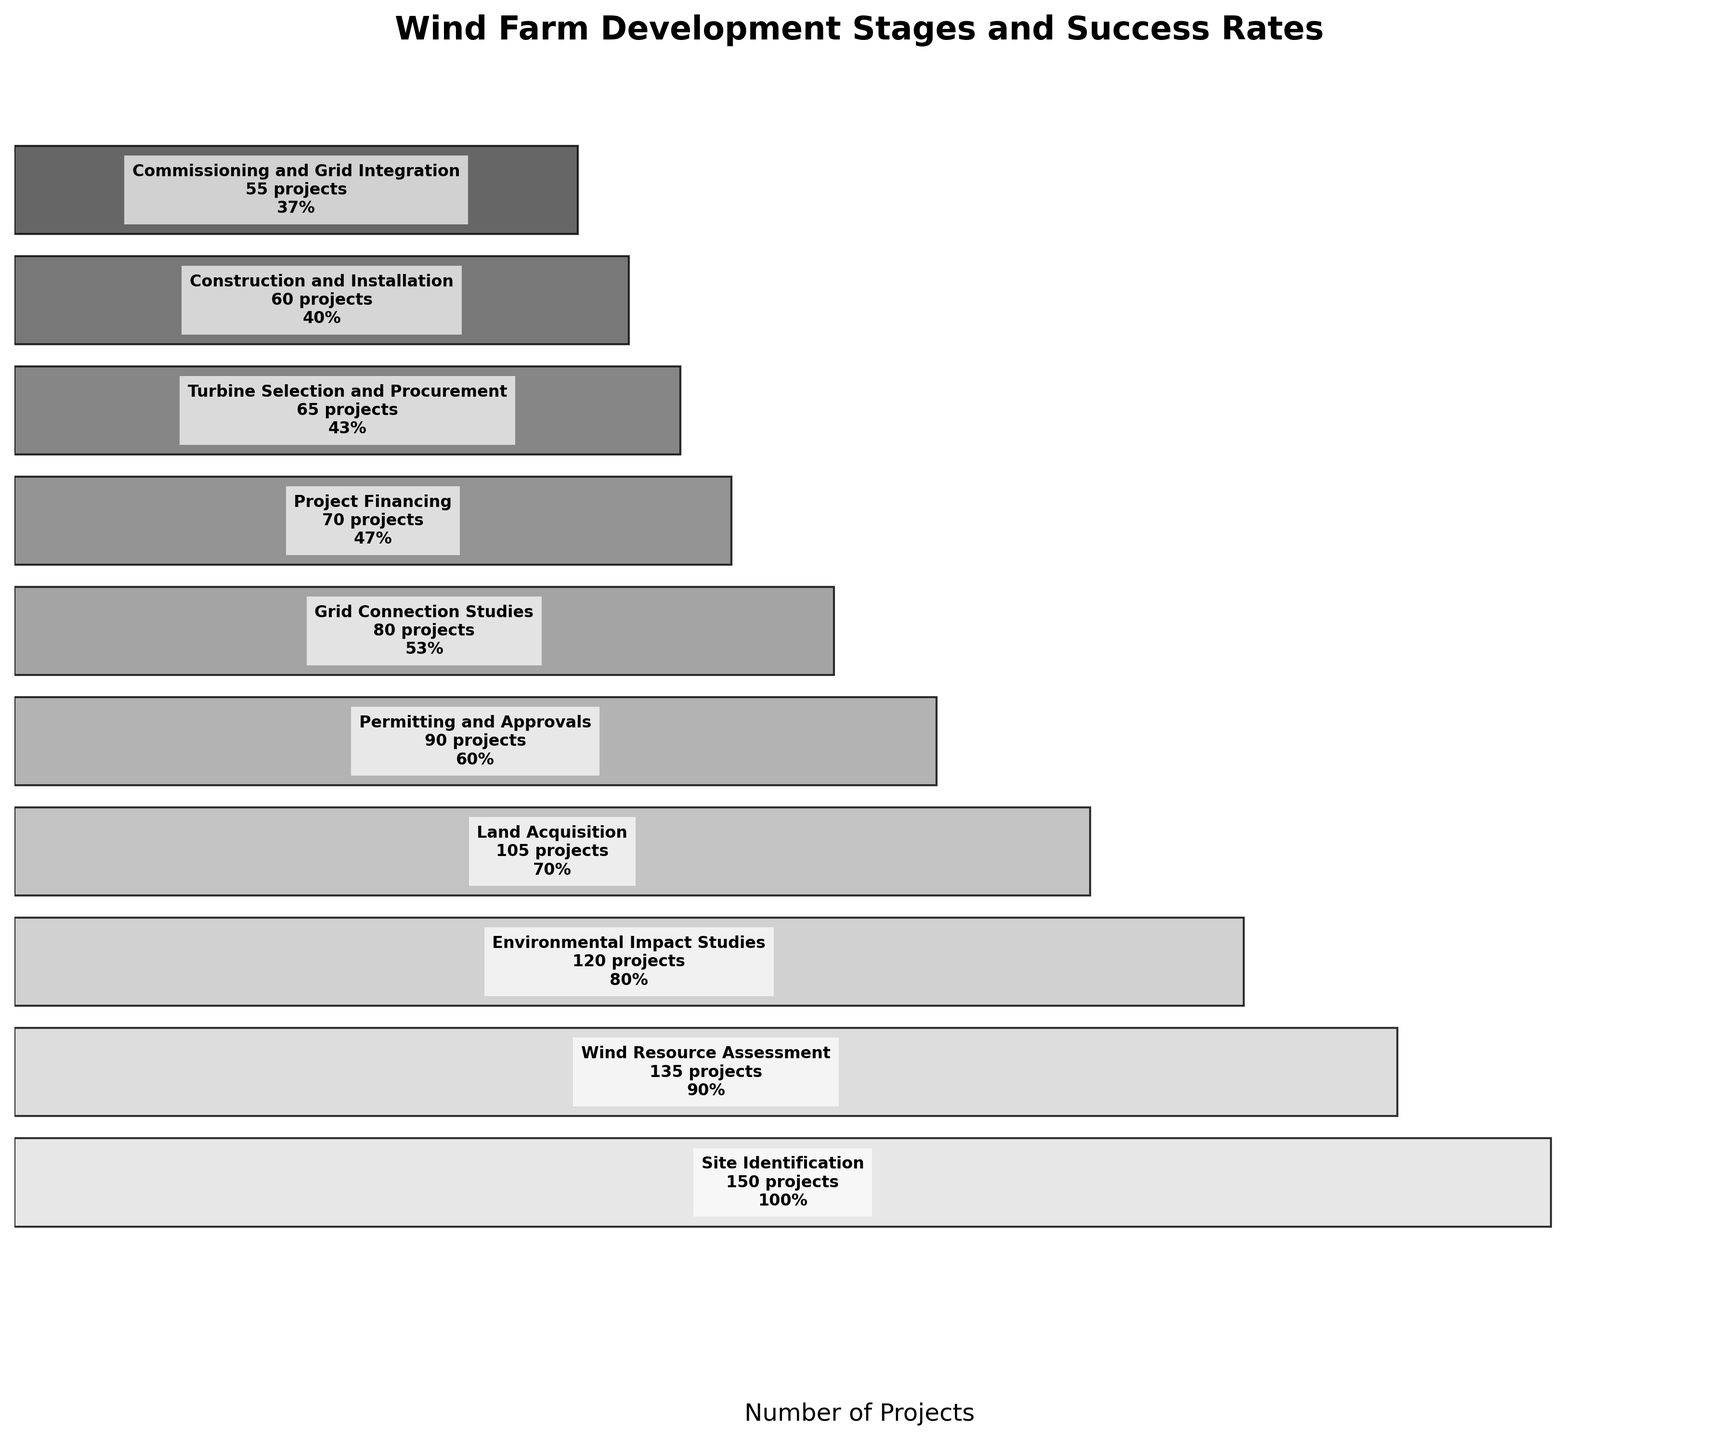What is the title of the funnel chart? The title is located at the top of the chart and it generally provides a summary of the information presented in the chart. In this case, the title reads: 'Wind Farm Development Stages and Success Rates'.
Answer: Wind Farm Development Stages and Success Rates How many stages are represented in the funnel chart? To determine this, count the number of distinct stages listed along the y-axis or within the funnel blocks. There are 10 stages starting from 'Site Identification' to 'Commissioning and Grid Integration'.
Answer: 10 At which stage do half or less of the initial projects still remain? Determine the stages where the remaining number of projects is less than or equal to half of the number of projects in the 'Site Identification' stage. Since 'Site Identification' has 150 projects, half would be 75. Beginning from the 'Grid Connection Studies' stage (80 projects), there are 70 or fewer projects.
Answer: Grid Connection Studies Which stage has the highest drop in the number of projects from the previous stage? To find the stage with the highest drop, calculate the difference in the number of projects between each successive stage and identify the maximum drop. The largest drop occurs between 'Environmental Impact Studies' (120 projects) and 'Land Acquisition' (105 projects), a drop of 15 projects.
Answer: Environmental Impact Studies to Land Acquisition What is the success rate for the 'Construction and Installation' stage? Find the 'Construction and Installation' stage on the y-axis or within the funnel blocks and look for the success rate mentioned. It is given as a percentage in the format 'xx%'. For 'Construction and Installation', it is 40%.
Answer: 40% How many projects reach the 'Turbine Selection and Procurement' stage? Identify the 'Turbine Selection and Procurement' stage within the funnel and note the number of projects mentioned. The number of projects for this stage is listed as 65.
Answer: 65 Is the success rate more than 50% for any stage beyond 'Grid Connection Studies'? Check each stage from 'Project Financing' to 'Commissioning and Grid Integration' and verify their success rates. All stages beyond 'Grid Connection Studies' have success rates less than or equal to 47%.
Answer: No Compare the number of projects that reach the final stage with those that complete the 'Site Identification' stage. The final stage 'Commissioning and Grid Integration' has 55 projects, while the initial 'Site Identification' stage has 150 projects. The final stage has 95 fewer projects.
Answer: 55 vs. 150 In which stage do we experience the first drop below 50% success rate? Examine the success rates for each stage and find the first stage where the success rate drops below 50%. The first stage with a success rate below 50% is 'Project Financing' with a success rate of 47%.
Answer: Project Financing 